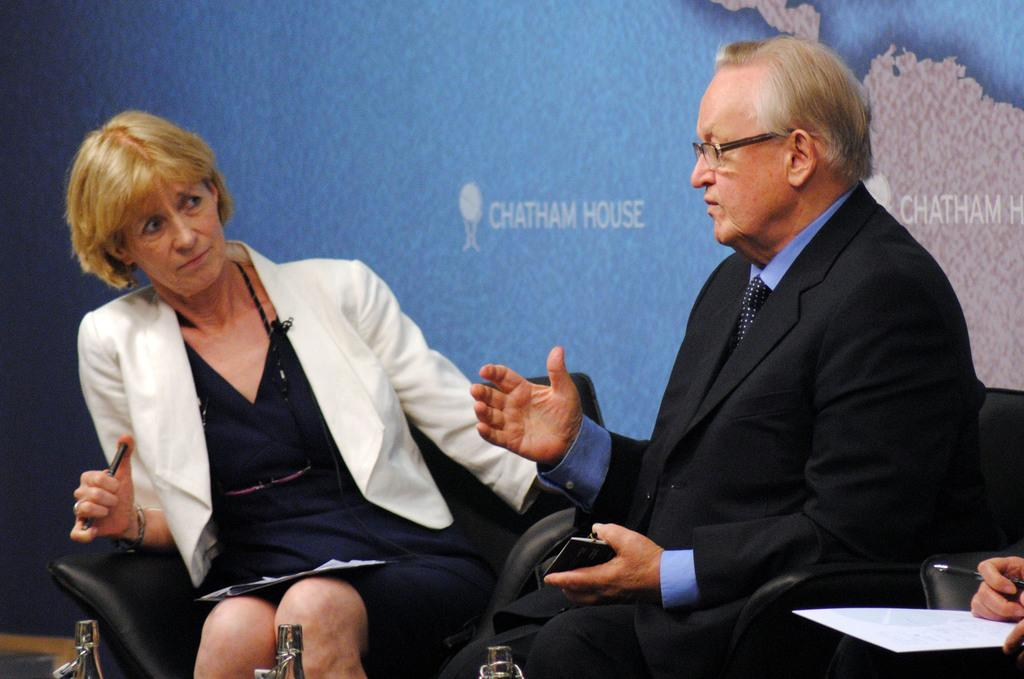Who is present in the image? There are people in the image. What are the people doing in the image? The people are seated on chairs. Can you describe the man on the right side of the image? The man on the right side of the image is wearing spectacles. Is there a stranger riding a bike on the sidewalk in the image? No, there is no stranger, bike, or sidewalk present in the image. 